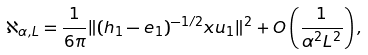<formula> <loc_0><loc_0><loc_500><loc_500>\aleph _ { \alpha , L } = \frac { 1 } { 6 \pi } \| ( h _ { 1 } - e _ { 1 } ) ^ { - 1 / 2 } x u _ { 1 } \| ^ { 2 } + O \left ( \frac { 1 } { \alpha ^ { 2 } L ^ { 2 } } \right ) ,</formula> 